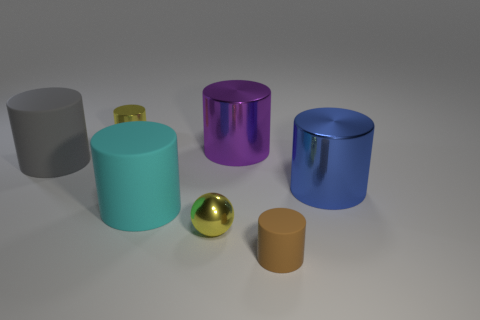Is there any other thing that has the same color as the metal ball?
Provide a succinct answer. Yes. Do the tiny metallic cylinder and the tiny matte object have the same color?
Your answer should be very brief. No. How many purple objects are either tiny cylinders or cylinders?
Make the answer very short. 1. Are there fewer yellow metal spheres behind the small brown cylinder than tiny yellow cylinders?
Offer a very short reply. No. There is a big rubber cylinder in front of the blue thing; how many small brown cylinders are behind it?
Provide a short and direct response. 0. How many other things are there of the same size as the brown cylinder?
Your answer should be very brief. 2. How many things are metal balls or large objects left of the small brown object?
Keep it short and to the point. 4. Is the number of cyan metal balls less than the number of big purple cylinders?
Ensure brevity in your answer.  Yes. There is a metallic cylinder that is on the right side of the small cylinder in front of the gray thing; what is its color?
Your answer should be very brief. Blue. What is the material of the purple object that is the same shape as the large cyan matte thing?
Provide a short and direct response. Metal. 